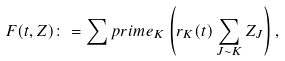Convert formula to latex. <formula><loc_0><loc_0><loc_500><loc_500>F ( t , Z ) \colon = \sum p r i m e _ { K } \left ( r _ { K } ( t ) \sum _ { J \sim K } Z _ { J } \right ) ,</formula> 